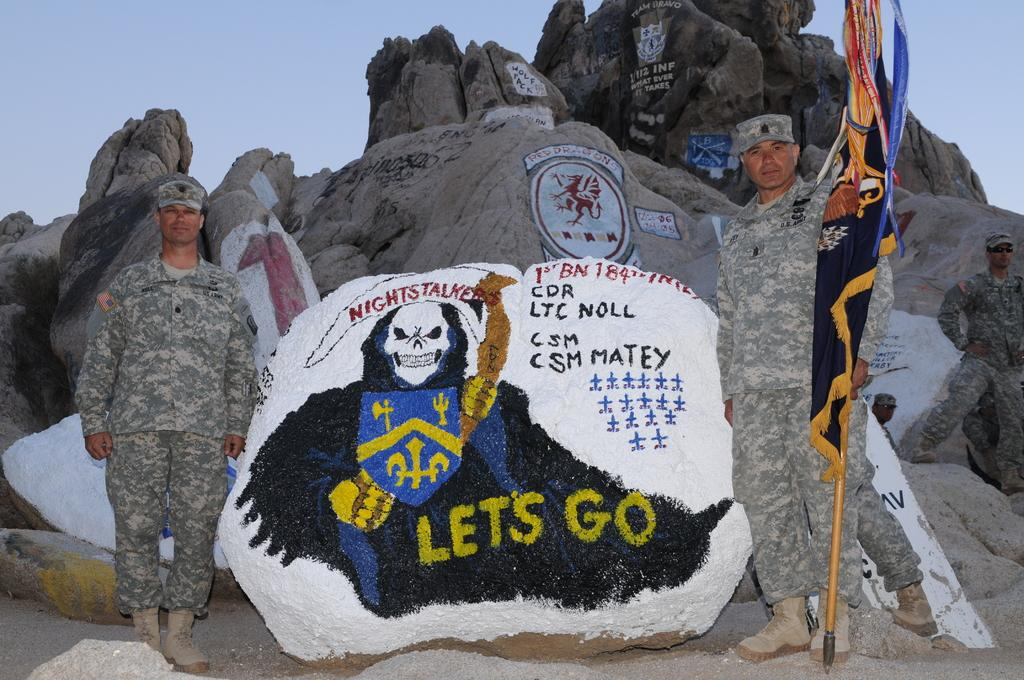What type of natural formation can be seen in the image? There are rocks in the image. What is depicted on the rocks? There is a painting on the rocks. What else is present in the image besides the rocks and painting? There are two soldiers standing in the image. What can be seen in the background of the image? The sky is visible in the background of the image. What type of vehicle is parked next to the rocks in the image? There is no vehicle present in the image; it features rocks, a painting, and two soldiers. What type of tool is being used by the soldiers in the image? There is no tool, such as scissors, depicted in the image; the soldiers are standing without any visible objects. 